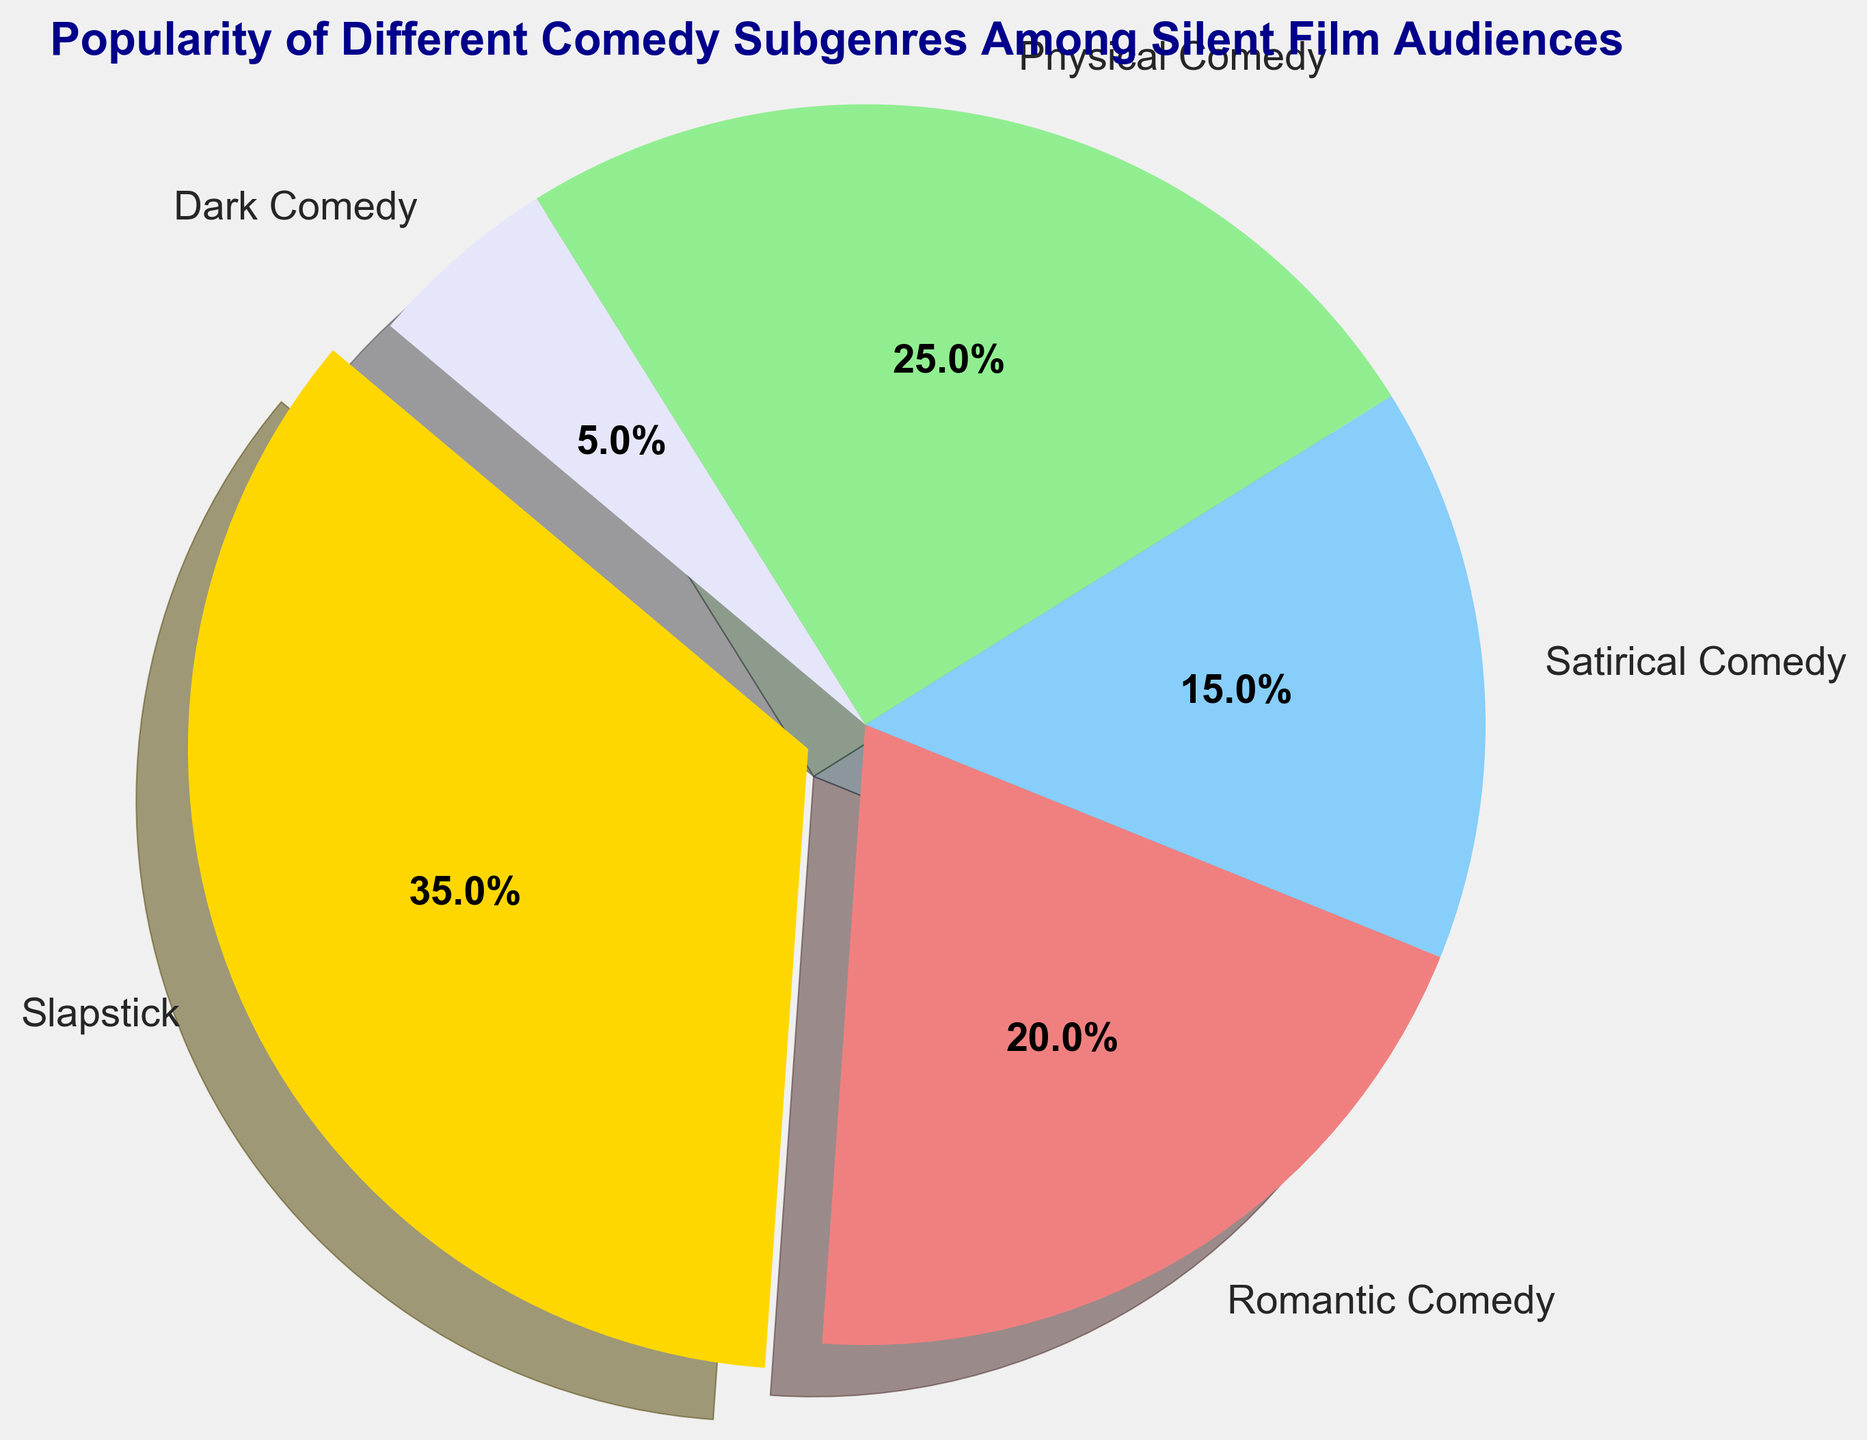What subgenre is the most popular among silent film audiences? Slapstick has the largest percentage slice in the pie chart.
Answer: Slapstick Which subgenre has the smallest popularity percentage? Dark Comedy occupies the smallest slice in the pie chart.
Answer: Dark Comedy What is the combined popularity percentage of Physical Comedy and Satirical Comedy? Physical Comedy is 25% and Satirical Comedy is 15%. Added together, they sum up to 25% + 15% = 40%.
Answer: 40% Is Romantic Comedy more popular than Satirical Comedy? Yes, Romantic Comedy has a popularity percentage of 20%, while Satirical Comedy has 15%.
Answer: Yes How much more popular is Slapstick compared to Dark Comedy? Slapstick has a popularity of 35% and Dark Comedy has 5%. The difference is 35% - 5% = 30%.
Answer: 30% Which subgenre is represented by the lightcoral color? The lightcoral color corresponds to the second slice, which is labeled as Romantic Comedy.
Answer: Romantic Comedy What fraction of the pie chart is made up by Slapstick and Physical Comedy together? Slapstick is 35% and Physical Comedy is 25%. Combined, they are 35% + 25% = 60%, which is equivalent to 60/100 or 3/5 of the pie chart.
Answer: 3/5 Is any subgenre more than twice as popular as Dark Comedy? Yes, Slapstick (35%) and Physical Comedy (25%) are both more than twice as popular as Dark Comedy (5%).
Answer: Yes What is the total popularity percentage of the three least popular subgenres? The three least popular subgenres are Dark Comedy (5%), Satirical Comedy (15%), and Romantic Comedy (20%). Summing them up gives 5% + 15% + 20% = 40%.
Answer: 40% Does the slice for Physical Comedy appear larger than the slice for Romantic Comedy? Yes, Physical Comedy is 25%, which is larger than Romantic Comedy's 20%.
Answer: Yes 